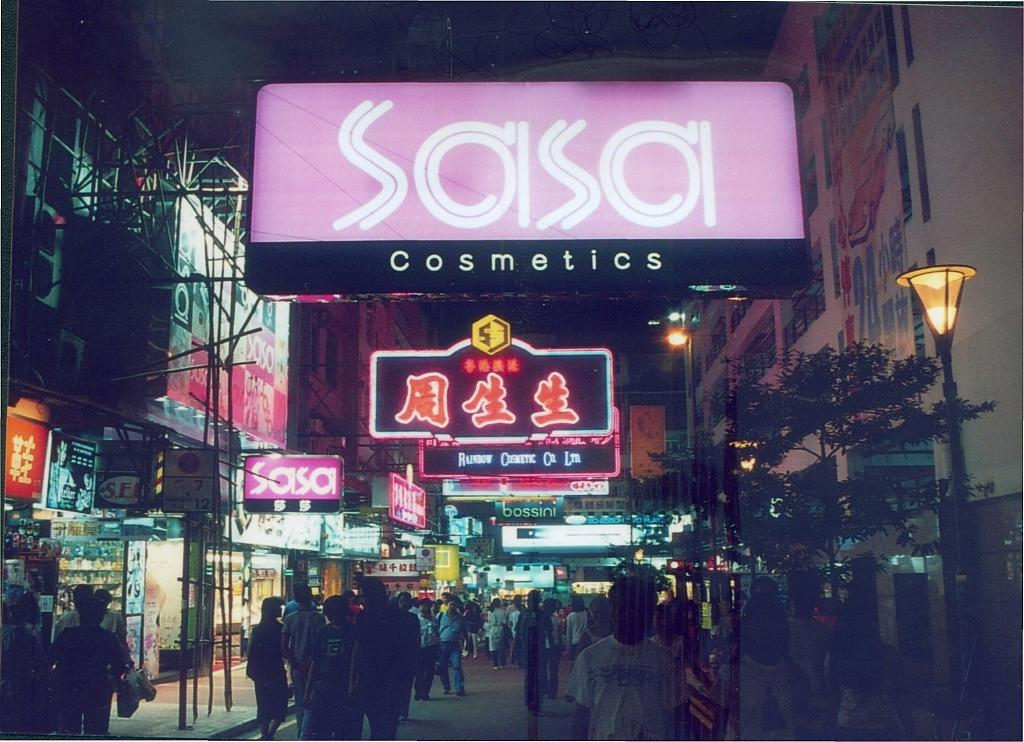What are the people in the image doing? The people in the image are walking on the road. What can be seen on both sides of the road? There are buildings on both the left and right sides of the road. What is written or displayed on the boards in the image? There are boards with text and logos in the image. Can you describe any other objects visible in the image? There are other objects visible in the image, but their specific details are not mentioned in the provided facts. What type of appliance can be seen falling off the building during the earthquake in the image? There is no earthquake or appliance falling off a building in the image. 